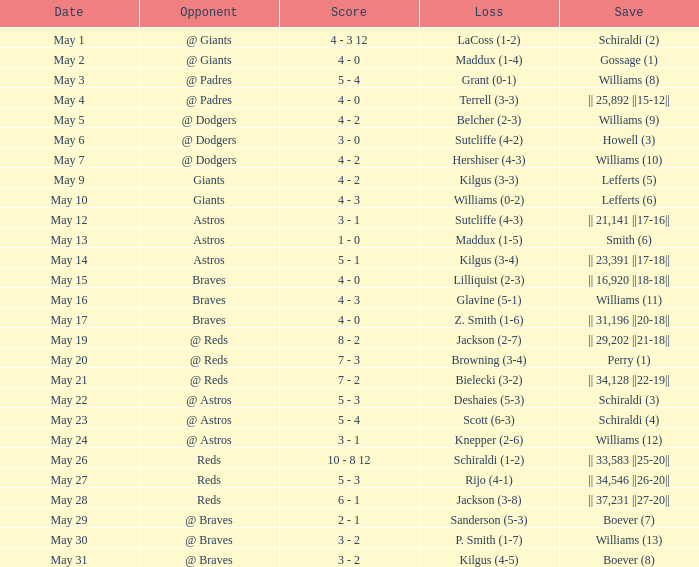Could you parse the entire table as a dict? {'header': ['Date', 'Opponent', 'Score', 'Loss', 'Save'], 'rows': [['May 1', '@ Giants', '4 - 3 12', 'LaCoss (1-2)', 'Schiraldi (2)'], ['May 2', '@ Giants', '4 - 0', 'Maddux (1-4)', 'Gossage (1)'], ['May 3', '@ Padres', '5 - 4', 'Grant (0-1)', 'Williams (8)'], ['May 4', '@ Padres', '4 - 0', 'Terrell (3-3)', '|| 25,892 ||15-12||'], ['May 5', '@ Dodgers', '4 - 2', 'Belcher (2-3)', 'Williams (9)'], ['May 6', '@ Dodgers', '3 - 0', 'Sutcliffe (4-2)', 'Howell (3)'], ['May 7', '@ Dodgers', '4 - 2', 'Hershiser (4-3)', 'Williams (10)'], ['May 9', 'Giants', '4 - 2', 'Kilgus (3-3)', 'Lefferts (5)'], ['May 10', 'Giants', '4 - 3', 'Williams (0-2)', 'Lefferts (6)'], ['May 12', 'Astros', '3 - 1', 'Sutcliffe (4-3)', '|| 21,141 ||17-16||'], ['May 13', 'Astros', '1 - 0', 'Maddux (1-5)', 'Smith (6)'], ['May 14', 'Astros', '5 - 1', 'Kilgus (3-4)', '|| 23,391 ||17-18||'], ['May 15', 'Braves', '4 - 0', 'Lilliquist (2-3)', '|| 16,920 ||18-18||'], ['May 16', 'Braves', '4 - 3', 'Glavine (5-1)', 'Williams (11)'], ['May 17', 'Braves', '4 - 0', 'Z. Smith (1-6)', '|| 31,196 ||20-18||'], ['May 19', '@ Reds', '8 - 2', 'Jackson (2-7)', '|| 29,202 ||21-18||'], ['May 20', '@ Reds', '7 - 3', 'Browning (3-4)', 'Perry (1)'], ['May 21', '@ Reds', '7 - 2', 'Bielecki (3-2)', '|| 34,128 ||22-19||'], ['May 22', '@ Astros', '5 - 3', 'Deshaies (5-3)', 'Schiraldi (3)'], ['May 23', '@ Astros', '5 - 4', 'Scott (6-3)', 'Schiraldi (4)'], ['May 24', '@ Astros', '3 - 1', 'Knepper (2-6)', 'Williams (12)'], ['May 26', 'Reds', '10 - 8 12', 'Schiraldi (1-2)', '|| 33,583 ||25-20||'], ['May 27', 'Reds', '5 - 3', 'Rijo (4-1)', '|| 34,546 ||26-20||'], ['May 28', 'Reds', '6 - 1', 'Jackson (3-8)', '|| 37,231 ||27-20||'], ['May 29', '@ Braves', '2 - 1', 'Sanderson (5-3)', 'Boever (7)'], ['May 30', '@ Braves', '3 - 2', 'P. Smith (1-7)', 'Williams (13)'], ['May 31', '@ Braves', '3 - 2', 'Kilgus (4-5)', 'Boever (8)']]} Name the loss for may 1 LaCoss (1-2). 